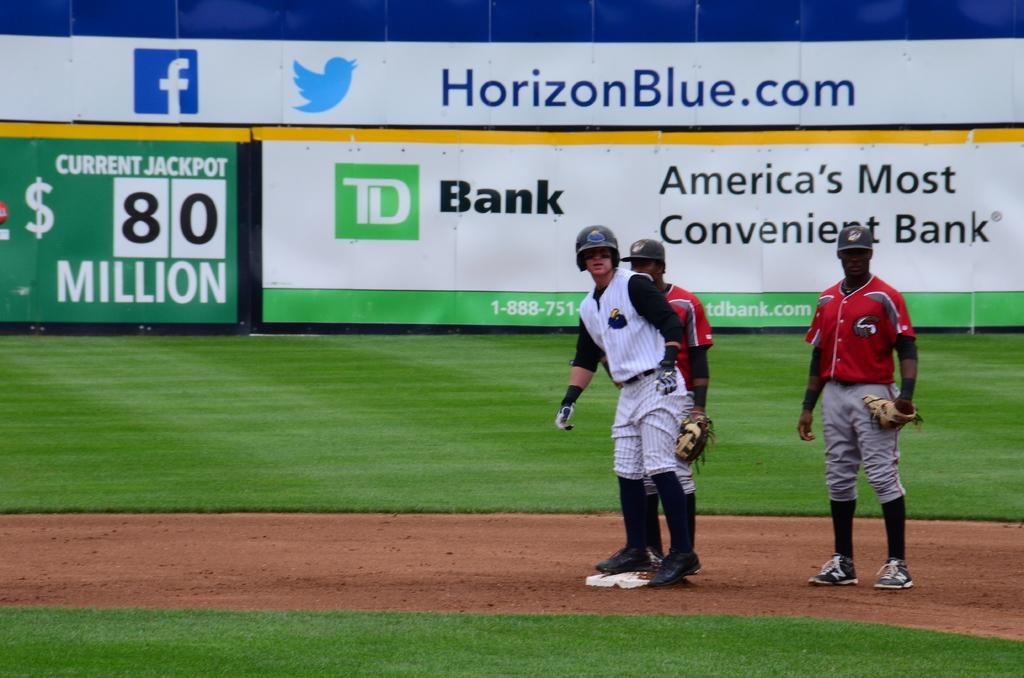<image>
Render a clear and concise summary of the photo. People are playing baseball on a field with a sign that has HorizonBlue.com on it. 